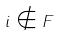<formula> <loc_0><loc_0><loc_500><loc_500>i \notin F</formula> 